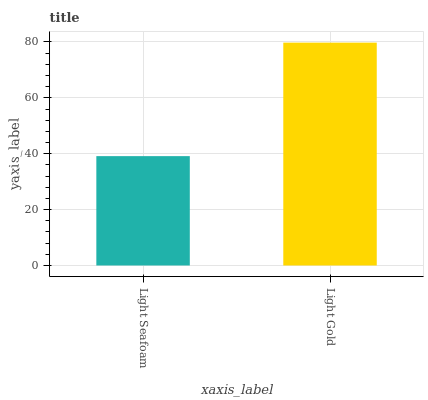Is Light Gold the minimum?
Answer yes or no. No. Is Light Gold greater than Light Seafoam?
Answer yes or no. Yes. Is Light Seafoam less than Light Gold?
Answer yes or no. Yes. Is Light Seafoam greater than Light Gold?
Answer yes or no. No. Is Light Gold less than Light Seafoam?
Answer yes or no. No. Is Light Gold the high median?
Answer yes or no. Yes. Is Light Seafoam the low median?
Answer yes or no. Yes. Is Light Seafoam the high median?
Answer yes or no. No. Is Light Gold the low median?
Answer yes or no. No. 